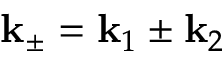Convert formula to latex. <formula><loc_0><loc_0><loc_500><loc_500>k _ { \pm } = k _ { 1 } \pm k _ { 2 }</formula> 